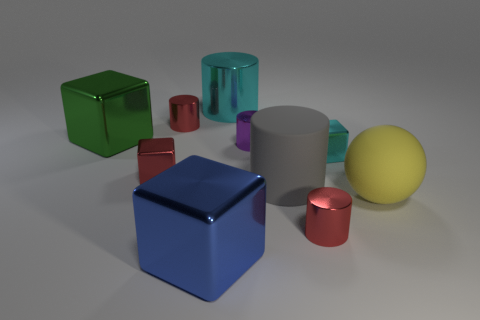Subtract all cyan cylinders. How many cylinders are left? 4 Subtract all large metal cylinders. How many cylinders are left? 4 Subtract all green cylinders. Subtract all green cubes. How many cylinders are left? 5 Subtract all balls. How many objects are left? 9 Subtract all tiny objects. Subtract all large yellow objects. How many objects are left? 4 Add 9 large yellow spheres. How many large yellow spheres are left? 10 Add 9 big gray matte things. How many big gray matte things exist? 10 Subtract 0 green cylinders. How many objects are left? 10 